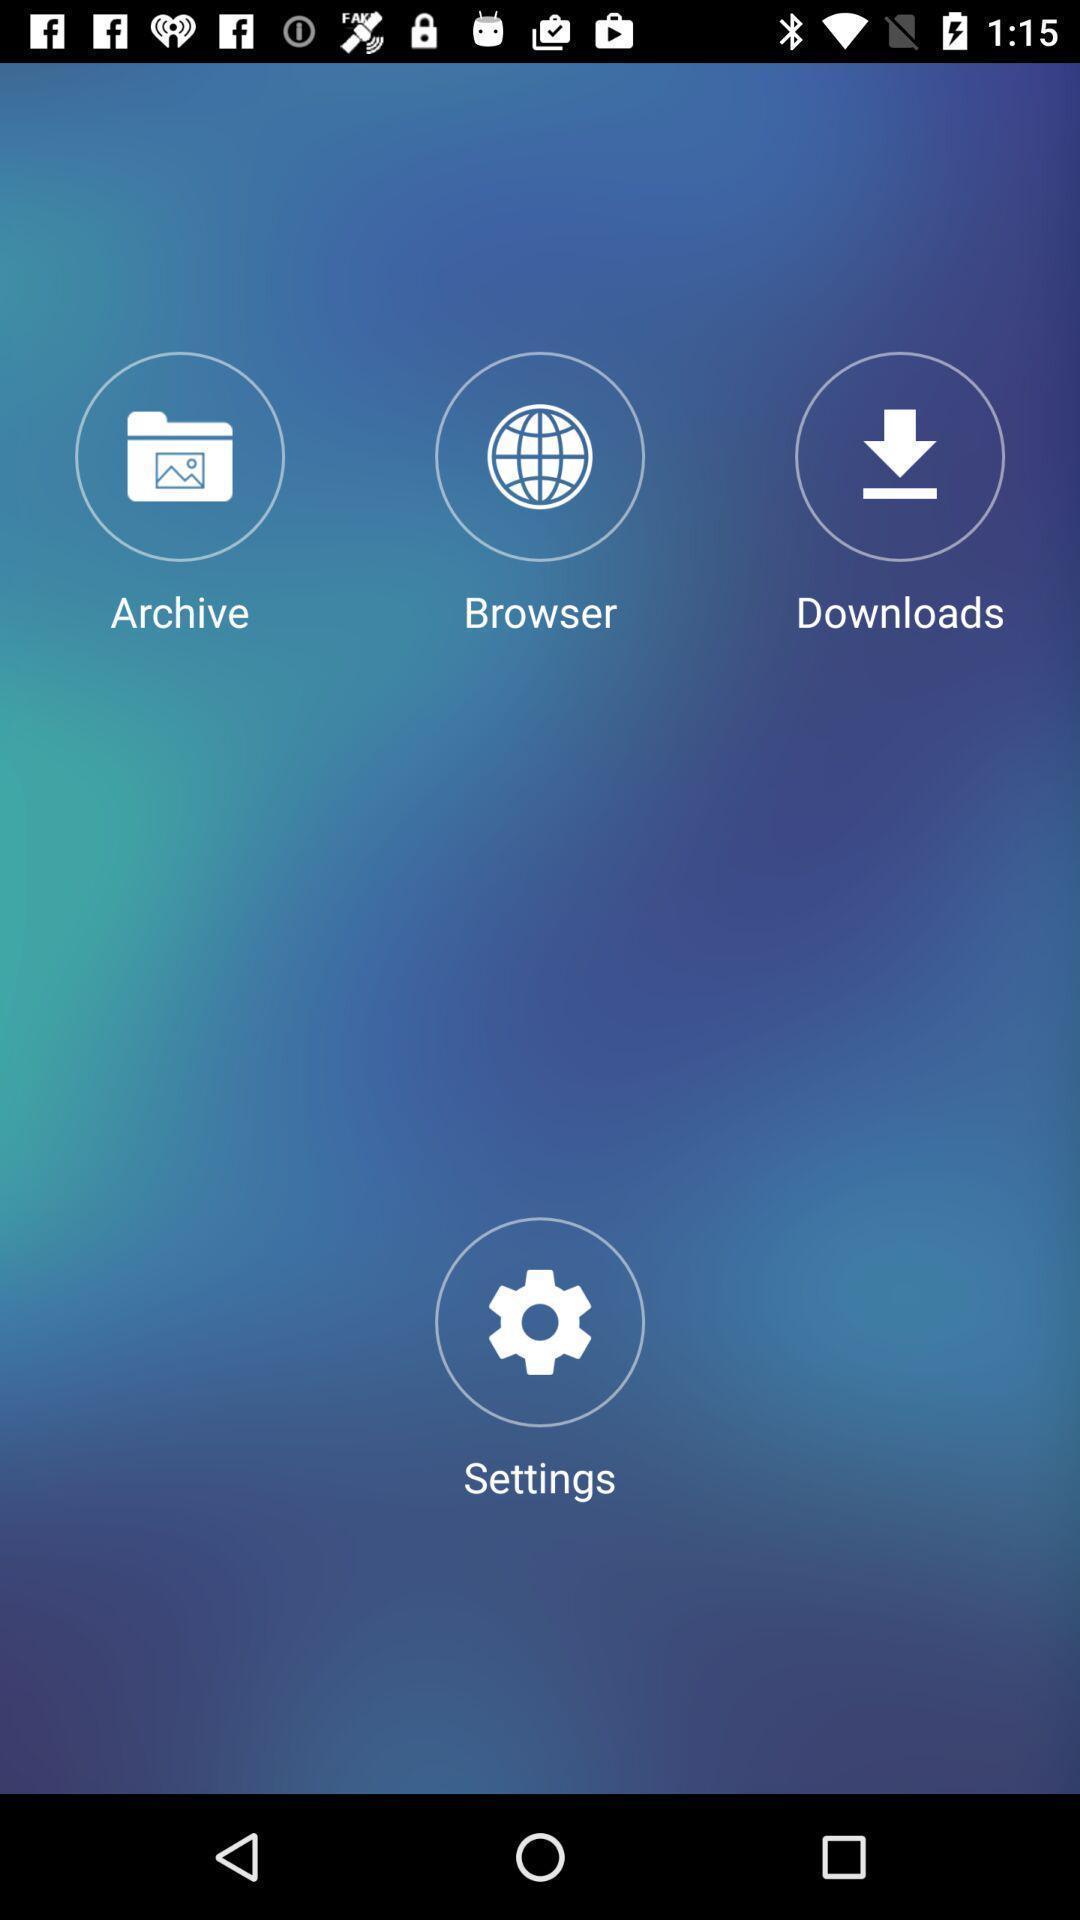Provide a description of this screenshot. Screen page displaying multiple options in calculator application. 